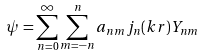Convert formula to latex. <formula><loc_0><loc_0><loc_500><loc_500>\psi = \sum _ { n = 0 } ^ { \infty } \sum _ { m = - n } ^ { n } a _ { n m } j _ { n } ( k r ) Y _ { n m }</formula> 